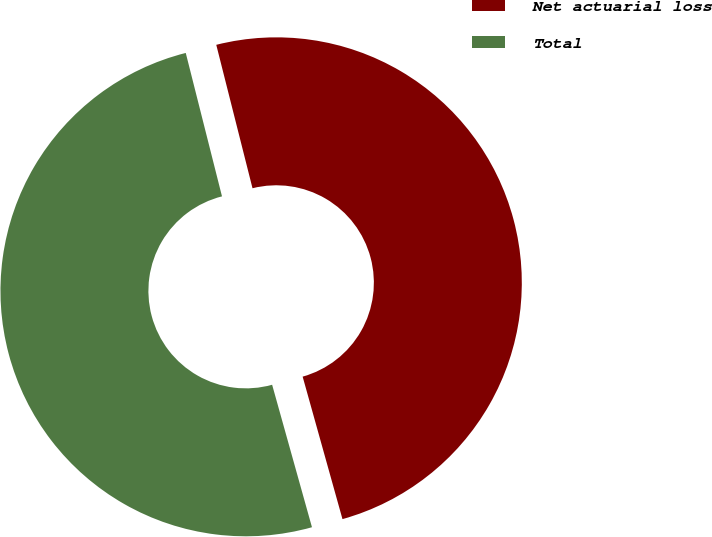<chart> <loc_0><loc_0><loc_500><loc_500><pie_chart><fcel>Net actuarial loss<fcel>Total<nl><fcel>49.6%<fcel>50.4%<nl></chart> 